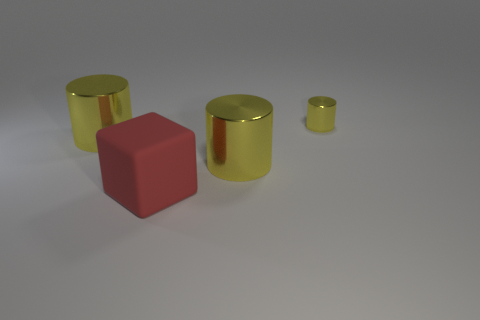How many yellow cylinders must be subtracted to get 1 yellow cylinders? 2 Subtract all tiny yellow cylinders. How many cylinders are left? 2 Add 1 cylinders. How many objects exist? 5 Subtract all cylinders. How many objects are left? 1 Subtract 0 gray blocks. How many objects are left? 4 Subtract all brown cylinders. Subtract all blue balls. How many cylinders are left? 3 Subtract all big cyan matte objects. Subtract all tiny yellow metallic cylinders. How many objects are left? 3 Add 2 big matte objects. How many big matte objects are left? 3 Add 3 big gray things. How many big gray things exist? 3 